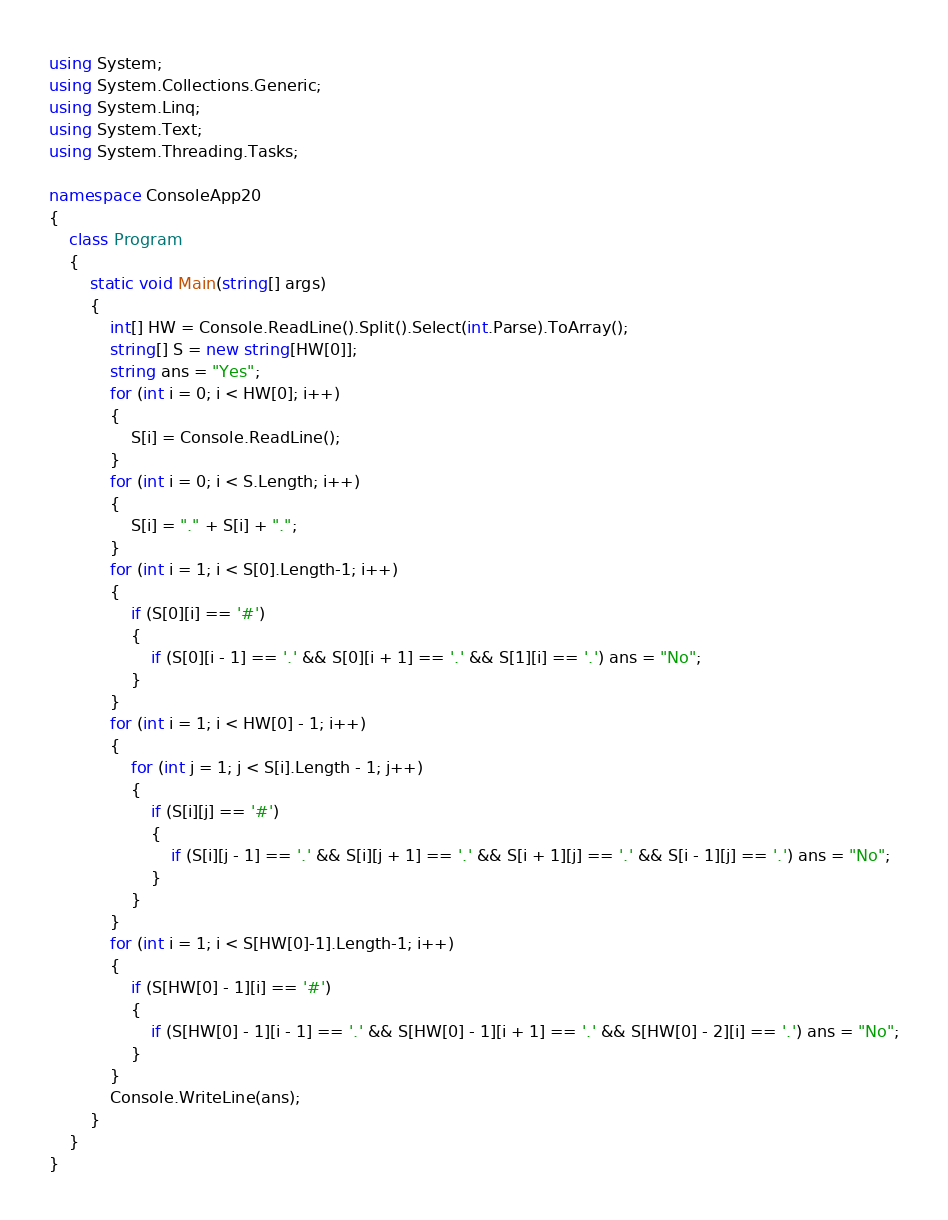Convert code to text. <code><loc_0><loc_0><loc_500><loc_500><_C#_>using System;
using System.Collections.Generic;
using System.Linq;
using System.Text;
using System.Threading.Tasks;

namespace ConsoleApp20
{
    class Program
    {
        static void Main(string[] args)
        {
            int[] HW = Console.ReadLine().Split().Select(int.Parse).ToArray();
            string[] S = new string[HW[0]];
            string ans = "Yes";
            for (int i = 0; i < HW[0]; i++)
            {
                S[i] = Console.ReadLine();
            }
            for (int i = 0; i < S.Length; i++)
            {
                S[i] = "." + S[i] + ".";
            }
            for (int i = 1; i < S[0].Length-1; i++)
            {
                if (S[0][i] == '#')
                {
                    if (S[0][i - 1] == '.' && S[0][i + 1] == '.' && S[1][i] == '.') ans = "No";
                }
            }
            for (int i = 1; i < HW[0] - 1; i++)
            {
                for (int j = 1; j < S[i].Length - 1; j++)
                {
                    if (S[i][j] == '#')
                    {
                        if (S[i][j - 1] == '.' && S[i][j + 1] == '.' && S[i + 1][j] == '.' && S[i - 1][j] == '.') ans = "No";
                    }
                }
            }
            for (int i = 1; i < S[HW[0]-1].Length-1; i++)
            {
                if (S[HW[0] - 1][i] == '#')
                {
                    if (S[HW[0] - 1][i - 1] == '.' && S[HW[0] - 1][i + 1] == '.' && S[HW[0] - 2][i] == '.') ans = "No";
                }
            }
            Console.WriteLine(ans);
        }
    }
}
</code> 